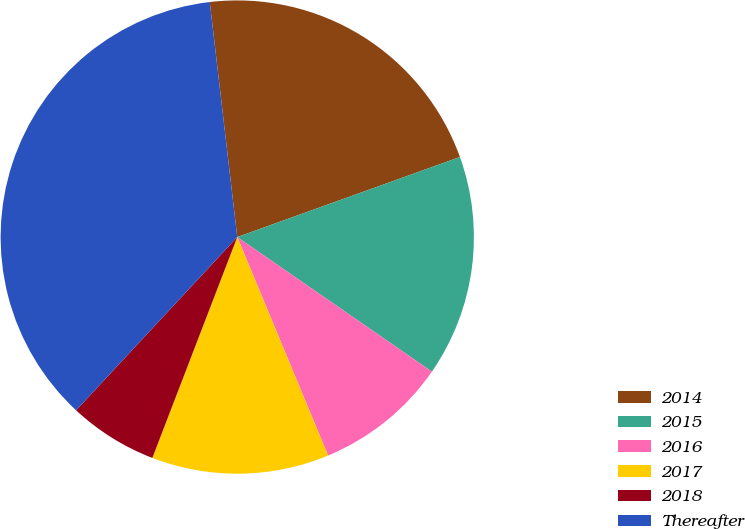Convert chart. <chart><loc_0><loc_0><loc_500><loc_500><pie_chart><fcel>2014<fcel>2015<fcel>2016<fcel>2017<fcel>2018<fcel>Thereafter<nl><fcel>21.36%<fcel>15.12%<fcel>9.1%<fcel>12.11%<fcel>6.08%<fcel>36.22%<nl></chart> 